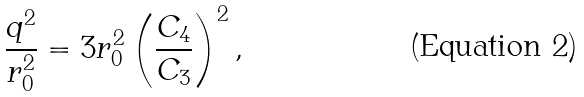<formula> <loc_0><loc_0><loc_500><loc_500>\frac { q ^ { 2 } } { r _ { 0 } ^ { 2 } } = 3 r _ { 0 } ^ { 2 } \left ( \frac { C _ { 4 } } { C _ { 3 } } \right ) ^ { 2 } ,</formula> 